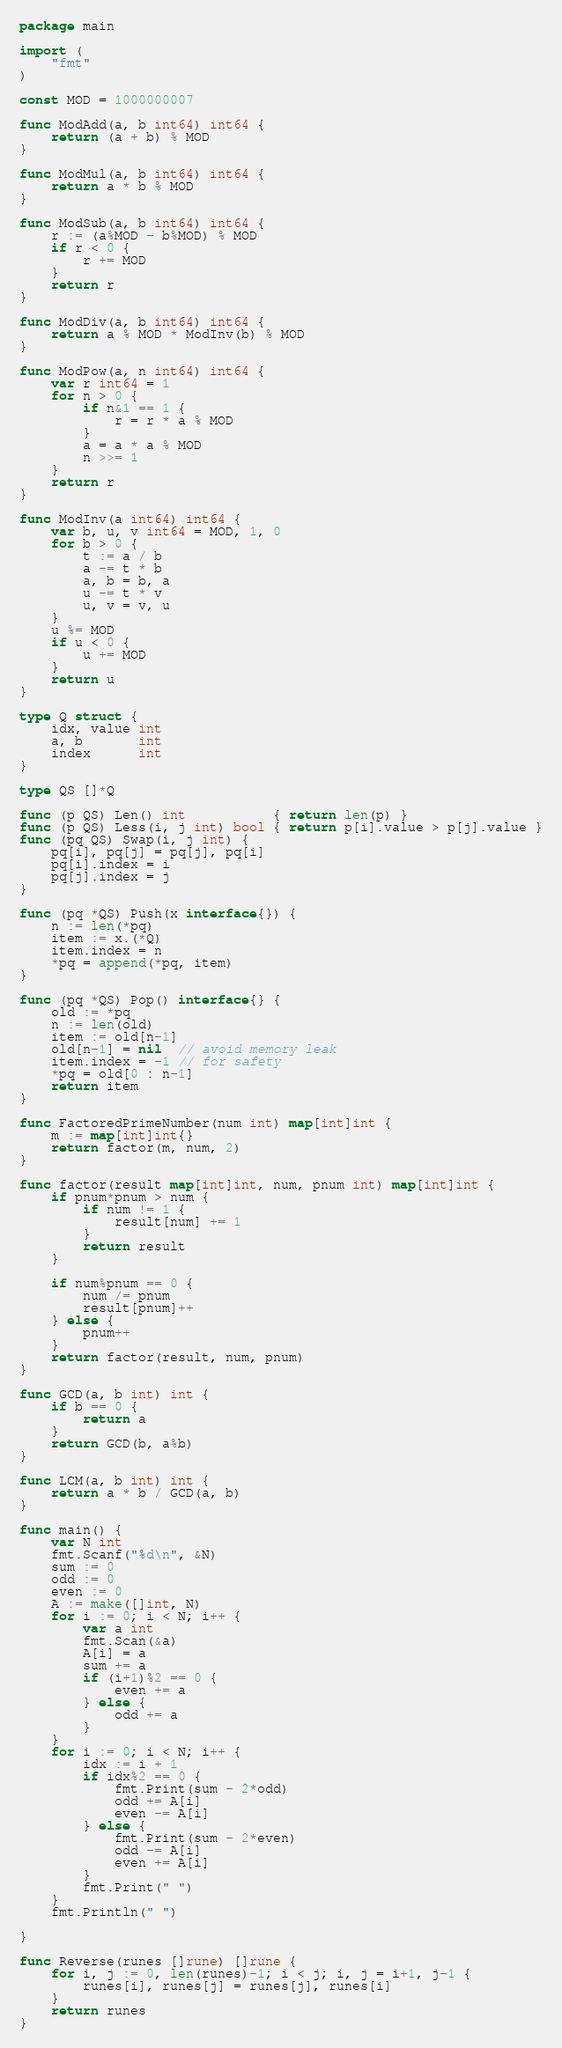<code> <loc_0><loc_0><loc_500><loc_500><_Go_>package main

import (
	"fmt"
)

const MOD = 1000000007

func ModAdd(a, b int64) int64 {
	return (a + b) % MOD
}

func ModMul(a, b int64) int64 {
	return a * b % MOD
}

func ModSub(a, b int64) int64 {
	r := (a%MOD - b%MOD) % MOD
	if r < 0 {
		r += MOD
	}
	return r
}

func ModDiv(a, b int64) int64 {
	return a % MOD * ModInv(b) % MOD
}

func ModPow(a, n int64) int64 {
	var r int64 = 1
	for n > 0 {
		if n&1 == 1 {
			r = r * a % MOD
		}
		a = a * a % MOD
		n >>= 1
	}
	return r
}

func ModInv(a int64) int64 {
	var b, u, v int64 = MOD, 1, 0
	for b > 0 {
		t := a / b
		a -= t * b
		a, b = b, a
		u -= t * v
		u, v = v, u
	}
	u %= MOD
	if u < 0 {
		u += MOD
	}
	return u
}

type Q struct {
	idx, value int
	a, b       int
	index      int
}

type QS []*Q

func (p QS) Len() int           { return len(p) }
func (p QS) Less(i, j int) bool { return p[i].value > p[j].value }
func (pq QS) Swap(i, j int) {
	pq[i], pq[j] = pq[j], pq[i]
	pq[i].index = i
	pq[j].index = j
}

func (pq *QS) Push(x interface{}) {
	n := len(*pq)
	item := x.(*Q)
	item.index = n
	*pq = append(*pq, item)
}

func (pq *QS) Pop() interface{} {
	old := *pq
	n := len(old)
	item := old[n-1]
	old[n-1] = nil  // avoid memory leak
	item.index = -1 // for safety
	*pq = old[0 : n-1]
	return item
}

func FactoredPrimeNumber(num int) map[int]int {
	m := map[int]int{}
	return factor(m, num, 2)
}

func factor(result map[int]int, num, pnum int) map[int]int {
	if pnum*pnum > num {
		if num != 1 {
			result[num] += 1
		}
		return result
	}

	if num%pnum == 0 {
		num /= pnum
		result[pnum]++
	} else {
		pnum++
	}
	return factor(result, num, pnum)
}

func GCD(a, b int) int {
	if b == 0 {
		return a
	}
	return GCD(b, a%b)
}

func LCM(a, b int) int {
	return a * b / GCD(a, b)
}

func main() {
	var N int
	fmt.Scanf("%d\n", &N)
	sum := 0
	odd := 0
	even := 0
	A := make([]int, N)
	for i := 0; i < N; i++ {
		var a int
		fmt.Scan(&a)
		A[i] = a
		sum += a
		if (i+1)%2 == 0 {
			even += a
		} else {
			odd += a
		}
	}
	for i := 0; i < N; i++ {
		idx := i + 1
		if idx%2 == 0 {
			fmt.Print(sum - 2*odd)
			odd += A[i]
			even -= A[i]
		} else {
			fmt.Print(sum - 2*even)
			odd -= A[i]
			even += A[i]
		}
		fmt.Print(" ")
	}
	fmt.Println(" ")

}

func Reverse(runes []rune) []rune {
	for i, j := 0, len(runes)-1; i < j; i, j = i+1, j-1 {
		runes[i], runes[j] = runes[j], runes[i]
	}
	return runes
}
</code> 